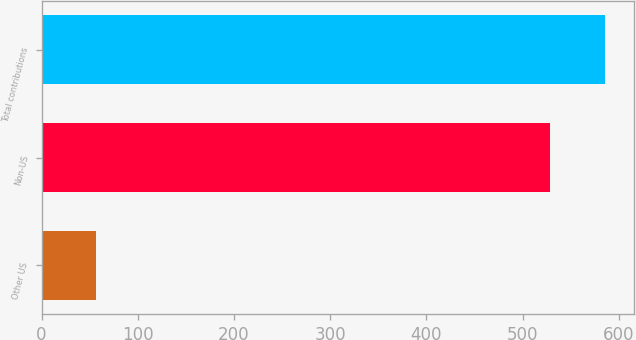Convert chart. <chart><loc_0><loc_0><loc_500><loc_500><bar_chart><fcel>Other US<fcel>Non-US<fcel>Total contributions<nl><fcel>57<fcel>529<fcel>586<nl></chart> 